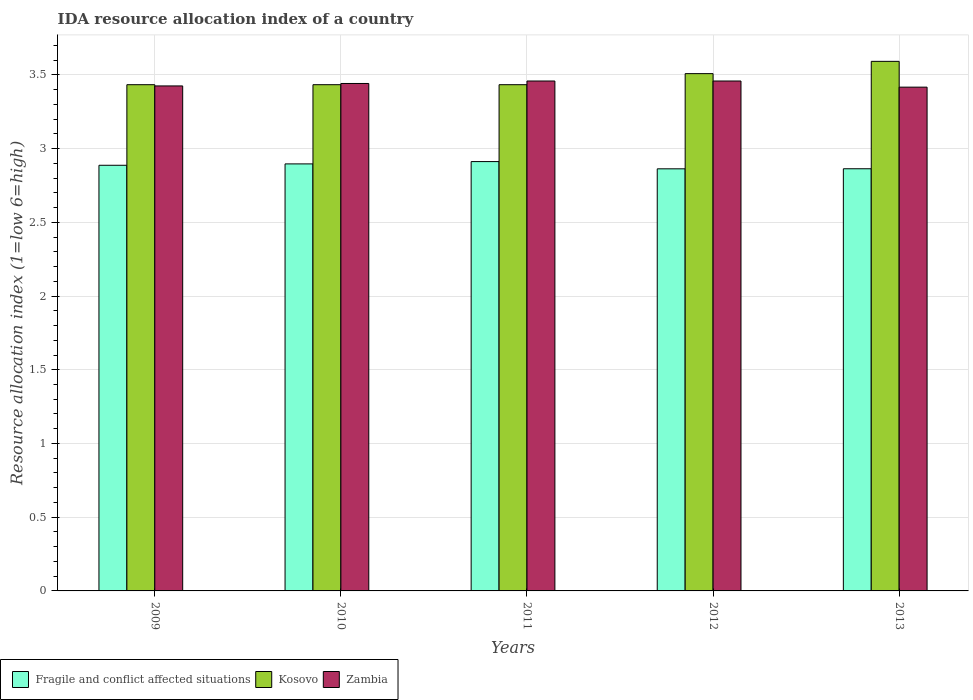Are the number of bars on each tick of the X-axis equal?
Your answer should be compact. Yes. How many bars are there on the 1st tick from the right?
Give a very brief answer. 3. What is the label of the 2nd group of bars from the left?
Keep it short and to the point. 2010. In how many cases, is the number of bars for a given year not equal to the number of legend labels?
Ensure brevity in your answer.  0. What is the IDA resource allocation index in Kosovo in 2009?
Offer a very short reply. 3.43. Across all years, what is the maximum IDA resource allocation index in Fragile and conflict affected situations?
Your answer should be compact. 2.91. Across all years, what is the minimum IDA resource allocation index in Kosovo?
Give a very brief answer. 3.43. In which year was the IDA resource allocation index in Fragile and conflict affected situations minimum?
Keep it short and to the point. 2012. What is the total IDA resource allocation index in Fragile and conflict affected situations in the graph?
Give a very brief answer. 14.42. What is the difference between the IDA resource allocation index in Zambia in 2010 and that in 2013?
Offer a very short reply. 0.02. What is the difference between the IDA resource allocation index in Kosovo in 2010 and the IDA resource allocation index in Fragile and conflict affected situations in 2013?
Provide a short and direct response. 0.57. What is the average IDA resource allocation index in Zambia per year?
Give a very brief answer. 3.44. In the year 2013, what is the difference between the IDA resource allocation index in Kosovo and IDA resource allocation index in Zambia?
Offer a very short reply. 0.17. In how many years, is the IDA resource allocation index in Kosovo greater than 1.2?
Provide a short and direct response. 5. What is the ratio of the IDA resource allocation index in Fragile and conflict affected situations in 2010 to that in 2012?
Ensure brevity in your answer.  1.01. Is the difference between the IDA resource allocation index in Kosovo in 2011 and 2013 greater than the difference between the IDA resource allocation index in Zambia in 2011 and 2013?
Ensure brevity in your answer.  No. What is the difference between the highest and the second highest IDA resource allocation index in Kosovo?
Offer a terse response. 0.08. What is the difference between the highest and the lowest IDA resource allocation index in Zambia?
Offer a terse response. 0.04. In how many years, is the IDA resource allocation index in Kosovo greater than the average IDA resource allocation index in Kosovo taken over all years?
Your answer should be compact. 2. Is the sum of the IDA resource allocation index in Kosovo in 2010 and 2012 greater than the maximum IDA resource allocation index in Zambia across all years?
Provide a succinct answer. Yes. What does the 1st bar from the left in 2011 represents?
Make the answer very short. Fragile and conflict affected situations. What does the 3rd bar from the right in 2011 represents?
Keep it short and to the point. Fragile and conflict affected situations. Is it the case that in every year, the sum of the IDA resource allocation index in Zambia and IDA resource allocation index in Fragile and conflict affected situations is greater than the IDA resource allocation index in Kosovo?
Your answer should be very brief. Yes. How many bars are there?
Provide a succinct answer. 15. Are all the bars in the graph horizontal?
Offer a very short reply. No. Does the graph contain any zero values?
Offer a terse response. No. Where does the legend appear in the graph?
Give a very brief answer. Bottom left. How are the legend labels stacked?
Make the answer very short. Horizontal. What is the title of the graph?
Keep it short and to the point. IDA resource allocation index of a country. What is the label or title of the Y-axis?
Provide a short and direct response. Resource allocation index (1=low 6=high). What is the Resource allocation index (1=low 6=high) of Fragile and conflict affected situations in 2009?
Your answer should be compact. 2.89. What is the Resource allocation index (1=low 6=high) in Kosovo in 2009?
Provide a short and direct response. 3.43. What is the Resource allocation index (1=low 6=high) in Zambia in 2009?
Provide a short and direct response. 3.42. What is the Resource allocation index (1=low 6=high) of Fragile and conflict affected situations in 2010?
Provide a short and direct response. 2.9. What is the Resource allocation index (1=low 6=high) of Kosovo in 2010?
Provide a succinct answer. 3.43. What is the Resource allocation index (1=low 6=high) in Zambia in 2010?
Provide a succinct answer. 3.44. What is the Resource allocation index (1=low 6=high) of Fragile and conflict affected situations in 2011?
Your response must be concise. 2.91. What is the Resource allocation index (1=low 6=high) in Kosovo in 2011?
Your answer should be very brief. 3.43. What is the Resource allocation index (1=low 6=high) of Zambia in 2011?
Your answer should be very brief. 3.46. What is the Resource allocation index (1=low 6=high) of Fragile and conflict affected situations in 2012?
Provide a short and direct response. 2.86. What is the Resource allocation index (1=low 6=high) of Kosovo in 2012?
Provide a short and direct response. 3.51. What is the Resource allocation index (1=low 6=high) in Zambia in 2012?
Offer a terse response. 3.46. What is the Resource allocation index (1=low 6=high) of Fragile and conflict affected situations in 2013?
Give a very brief answer. 2.86. What is the Resource allocation index (1=low 6=high) of Kosovo in 2013?
Provide a short and direct response. 3.59. What is the Resource allocation index (1=low 6=high) of Zambia in 2013?
Your response must be concise. 3.42. Across all years, what is the maximum Resource allocation index (1=low 6=high) in Fragile and conflict affected situations?
Your response must be concise. 2.91. Across all years, what is the maximum Resource allocation index (1=low 6=high) in Kosovo?
Offer a very short reply. 3.59. Across all years, what is the maximum Resource allocation index (1=low 6=high) in Zambia?
Keep it short and to the point. 3.46. Across all years, what is the minimum Resource allocation index (1=low 6=high) of Fragile and conflict affected situations?
Ensure brevity in your answer.  2.86. Across all years, what is the minimum Resource allocation index (1=low 6=high) in Kosovo?
Keep it short and to the point. 3.43. Across all years, what is the minimum Resource allocation index (1=low 6=high) of Zambia?
Give a very brief answer. 3.42. What is the total Resource allocation index (1=low 6=high) in Fragile and conflict affected situations in the graph?
Keep it short and to the point. 14.42. What is the total Resource allocation index (1=low 6=high) in Kosovo in the graph?
Keep it short and to the point. 17.4. What is the total Resource allocation index (1=low 6=high) in Zambia in the graph?
Provide a succinct answer. 17.2. What is the difference between the Resource allocation index (1=low 6=high) in Fragile and conflict affected situations in 2009 and that in 2010?
Provide a succinct answer. -0.01. What is the difference between the Resource allocation index (1=low 6=high) of Zambia in 2009 and that in 2010?
Your answer should be compact. -0.02. What is the difference between the Resource allocation index (1=low 6=high) in Fragile and conflict affected situations in 2009 and that in 2011?
Provide a short and direct response. -0.03. What is the difference between the Resource allocation index (1=low 6=high) in Zambia in 2009 and that in 2011?
Your answer should be very brief. -0.03. What is the difference between the Resource allocation index (1=low 6=high) in Fragile and conflict affected situations in 2009 and that in 2012?
Provide a short and direct response. 0.02. What is the difference between the Resource allocation index (1=low 6=high) of Kosovo in 2009 and that in 2012?
Your answer should be compact. -0.07. What is the difference between the Resource allocation index (1=low 6=high) in Zambia in 2009 and that in 2012?
Your answer should be compact. -0.03. What is the difference between the Resource allocation index (1=low 6=high) of Fragile and conflict affected situations in 2009 and that in 2013?
Offer a very short reply. 0.02. What is the difference between the Resource allocation index (1=low 6=high) in Kosovo in 2009 and that in 2013?
Make the answer very short. -0.16. What is the difference between the Resource allocation index (1=low 6=high) of Zambia in 2009 and that in 2013?
Offer a terse response. 0.01. What is the difference between the Resource allocation index (1=low 6=high) in Fragile and conflict affected situations in 2010 and that in 2011?
Make the answer very short. -0.02. What is the difference between the Resource allocation index (1=low 6=high) in Kosovo in 2010 and that in 2011?
Your answer should be compact. 0. What is the difference between the Resource allocation index (1=low 6=high) in Zambia in 2010 and that in 2011?
Provide a short and direct response. -0.02. What is the difference between the Resource allocation index (1=low 6=high) in Fragile and conflict affected situations in 2010 and that in 2012?
Offer a very short reply. 0.03. What is the difference between the Resource allocation index (1=low 6=high) in Kosovo in 2010 and that in 2012?
Offer a terse response. -0.07. What is the difference between the Resource allocation index (1=low 6=high) of Zambia in 2010 and that in 2012?
Provide a short and direct response. -0.02. What is the difference between the Resource allocation index (1=low 6=high) in Fragile and conflict affected situations in 2010 and that in 2013?
Your response must be concise. 0.03. What is the difference between the Resource allocation index (1=low 6=high) in Kosovo in 2010 and that in 2013?
Ensure brevity in your answer.  -0.16. What is the difference between the Resource allocation index (1=low 6=high) of Zambia in 2010 and that in 2013?
Offer a terse response. 0.03. What is the difference between the Resource allocation index (1=low 6=high) in Fragile and conflict affected situations in 2011 and that in 2012?
Make the answer very short. 0.05. What is the difference between the Resource allocation index (1=low 6=high) in Kosovo in 2011 and that in 2012?
Make the answer very short. -0.07. What is the difference between the Resource allocation index (1=low 6=high) in Zambia in 2011 and that in 2012?
Your response must be concise. 0. What is the difference between the Resource allocation index (1=low 6=high) in Fragile and conflict affected situations in 2011 and that in 2013?
Make the answer very short. 0.05. What is the difference between the Resource allocation index (1=low 6=high) of Kosovo in 2011 and that in 2013?
Ensure brevity in your answer.  -0.16. What is the difference between the Resource allocation index (1=low 6=high) in Zambia in 2011 and that in 2013?
Offer a very short reply. 0.04. What is the difference between the Resource allocation index (1=low 6=high) of Fragile and conflict affected situations in 2012 and that in 2013?
Keep it short and to the point. -0. What is the difference between the Resource allocation index (1=low 6=high) in Kosovo in 2012 and that in 2013?
Your answer should be very brief. -0.08. What is the difference between the Resource allocation index (1=low 6=high) in Zambia in 2012 and that in 2013?
Your answer should be compact. 0.04. What is the difference between the Resource allocation index (1=low 6=high) in Fragile and conflict affected situations in 2009 and the Resource allocation index (1=low 6=high) in Kosovo in 2010?
Provide a succinct answer. -0.55. What is the difference between the Resource allocation index (1=low 6=high) in Fragile and conflict affected situations in 2009 and the Resource allocation index (1=low 6=high) in Zambia in 2010?
Your answer should be very brief. -0.55. What is the difference between the Resource allocation index (1=low 6=high) in Kosovo in 2009 and the Resource allocation index (1=low 6=high) in Zambia in 2010?
Offer a very short reply. -0.01. What is the difference between the Resource allocation index (1=low 6=high) in Fragile and conflict affected situations in 2009 and the Resource allocation index (1=low 6=high) in Kosovo in 2011?
Provide a short and direct response. -0.55. What is the difference between the Resource allocation index (1=low 6=high) in Fragile and conflict affected situations in 2009 and the Resource allocation index (1=low 6=high) in Zambia in 2011?
Make the answer very short. -0.57. What is the difference between the Resource allocation index (1=low 6=high) in Kosovo in 2009 and the Resource allocation index (1=low 6=high) in Zambia in 2011?
Your response must be concise. -0.03. What is the difference between the Resource allocation index (1=low 6=high) of Fragile and conflict affected situations in 2009 and the Resource allocation index (1=low 6=high) of Kosovo in 2012?
Provide a succinct answer. -0.62. What is the difference between the Resource allocation index (1=low 6=high) in Fragile and conflict affected situations in 2009 and the Resource allocation index (1=low 6=high) in Zambia in 2012?
Give a very brief answer. -0.57. What is the difference between the Resource allocation index (1=low 6=high) in Kosovo in 2009 and the Resource allocation index (1=low 6=high) in Zambia in 2012?
Ensure brevity in your answer.  -0.03. What is the difference between the Resource allocation index (1=low 6=high) in Fragile and conflict affected situations in 2009 and the Resource allocation index (1=low 6=high) in Kosovo in 2013?
Provide a short and direct response. -0.7. What is the difference between the Resource allocation index (1=low 6=high) in Fragile and conflict affected situations in 2009 and the Resource allocation index (1=low 6=high) in Zambia in 2013?
Your answer should be very brief. -0.53. What is the difference between the Resource allocation index (1=low 6=high) of Kosovo in 2009 and the Resource allocation index (1=low 6=high) of Zambia in 2013?
Your answer should be compact. 0.02. What is the difference between the Resource allocation index (1=low 6=high) of Fragile and conflict affected situations in 2010 and the Resource allocation index (1=low 6=high) of Kosovo in 2011?
Ensure brevity in your answer.  -0.54. What is the difference between the Resource allocation index (1=low 6=high) in Fragile and conflict affected situations in 2010 and the Resource allocation index (1=low 6=high) in Zambia in 2011?
Provide a short and direct response. -0.56. What is the difference between the Resource allocation index (1=low 6=high) in Kosovo in 2010 and the Resource allocation index (1=low 6=high) in Zambia in 2011?
Your answer should be very brief. -0.03. What is the difference between the Resource allocation index (1=low 6=high) in Fragile and conflict affected situations in 2010 and the Resource allocation index (1=low 6=high) in Kosovo in 2012?
Provide a succinct answer. -0.61. What is the difference between the Resource allocation index (1=low 6=high) in Fragile and conflict affected situations in 2010 and the Resource allocation index (1=low 6=high) in Zambia in 2012?
Your answer should be compact. -0.56. What is the difference between the Resource allocation index (1=low 6=high) of Kosovo in 2010 and the Resource allocation index (1=low 6=high) of Zambia in 2012?
Your response must be concise. -0.03. What is the difference between the Resource allocation index (1=low 6=high) in Fragile and conflict affected situations in 2010 and the Resource allocation index (1=low 6=high) in Kosovo in 2013?
Provide a short and direct response. -0.7. What is the difference between the Resource allocation index (1=low 6=high) of Fragile and conflict affected situations in 2010 and the Resource allocation index (1=low 6=high) of Zambia in 2013?
Provide a succinct answer. -0.52. What is the difference between the Resource allocation index (1=low 6=high) in Kosovo in 2010 and the Resource allocation index (1=low 6=high) in Zambia in 2013?
Keep it short and to the point. 0.02. What is the difference between the Resource allocation index (1=low 6=high) of Fragile and conflict affected situations in 2011 and the Resource allocation index (1=low 6=high) of Kosovo in 2012?
Give a very brief answer. -0.6. What is the difference between the Resource allocation index (1=low 6=high) of Fragile and conflict affected situations in 2011 and the Resource allocation index (1=low 6=high) of Zambia in 2012?
Offer a very short reply. -0.55. What is the difference between the Resource allocation index (1=low 6=high) of Kosovo in 2011 and the Resource allocation index (1=low 6=high) of Zambia in 2012?
Offer a very short reply. -0.03. What is the difference between the Resource allocation index (1=low 6=high) of Fragile and conflict affected situations in 2011 and the Resource allocation index (1=low 6=high) of Kosovo in 2013?
Provide a short and direct response. -0.68. What is the difference between the Resource allocation index (1=low 6=high) in Fragile and conflict affected situations in 2011 and the Resource allocation index (1=low 6=high) in Zambia in 2013?
Offer a terse response. -0.5. What is the difference between the Resource allocation index (1=low 6=high) in Kosovo in 2011 and the Resource allocation index (1=low 6=high) in Zambia in 2013?
Your response must be concise. 0.02. What is the difference between the Resource allocation index (1=low 6=high) of Fragile and conflict affected situations in 2012 and the Resource allocation index (1=low 6=high) of Kosovo in 2013?
Offer a terse response. -0.73. What is the difference between the Resource allocation index (1=low 6=high) of Fragile and conflict affected situations in 2012 and the Resource allocation index (1=low 6=high) of Zambia in 2013?
Give a very brief answer. -0.55. What is the difference between the Resource allocation index (1=low 6=high) of Kosovo in 2012 and the Resource allocation index (1=low 6=high) of Zambia in 2013?
Provide a succinct answer. 0.09. What is the average Resource allocation index (1=low 6=high) of Fragile and conflict affected situations per year?
Your answer should be very brief. 2.88. What is the average Resource allocation index (1=low 6=high) in Kosovo per year?
Your answer should be compact. 3.48. What is the average Resource allocation index (1=low 6=high) of Zambia per year?
Ensure brevity in your answer.  3.44. In the year 2009, what is the difference between the Resource allocation index (1=low 6=high) of Fragile and conflict affected situations and Resource allocation index (1=low 6=high) of Kosovo?
Give a very brief answer. -0.55. In the year 2009, what is the difference between the Resource allocation index (1=low 6=high) in Fragile and conflict affected situations and Resource allocation index (1=low 6=high) in Zambia?
Your answer should be compact. -0.54. In the year 2009, what is the difference between the Resource allocation index (1=low 6=high) of Kosovo and Resource allocation index (1=low 6=high) of Zambia?
Provide a succinct answer. 0.01. In the year 2010, what is the difference between the Resource allocation index (1=low 6=high) of Fragile and conflict affected situations and Resource allocation index (1=low 6=high) of Kosovo?
Keep it short and to the point. -0.54. In the year 2010, what is the difference between the Resource allocation index (1=low 6=high) in Fragile and conflict affected situations and Resource allocation index (1=low 6=high) in Zambia?
Your response must be concise. -0.55. In the year 2010, what is the difference between the Resource allocation index (1=low 6=high) of Kosovo and Resource allocation index (1=low 6=high) of Zambia?
Your answer should be compact. -0.01. In the year 2011, what is the difference between the Resource allocation index (1=low 6=high) of Fragile and conflict affected situations and Resource allocation index (1=low 6=high) of Kosovo?
Make the answer very short. -0.52. In the year 2011, what is the difference between the Resource allocation index (1=low 6=high) in Fragile and conflict affected situations and Resource allocation index (1=low 6=high) in Zambia?
Your response must be concise. -0.55. In the year 2011, what is the difference between the Resource allocation index (1=low 6=high) of Kosovo and Resource allocation index (1=low 6=high) of Zambia?
Make the answer very short. -0.03. In the year 2012, what is the difference between the Resource allocation index (1=low 6=high) of Fragile and conflict affected situations and Resource allocation index (1=low 6=high) of Kosovo?
Provide a short and direct response. -0.65. In the year 2012, what is the difference between the Resource allocation index (1=low 6=high) of Fragile and conflict affected situations and Resource allocation index (1=low 6=high) of Zambia?
Your answer should be very brief. -0.6. In the year 2012, what is the difference between the Resource allocation index (1=low 6=high) of Kosovo and Resource allocation index (1=low 6=high) of Zambia?
Provide a short and direct response. 0.05. In the year 2013, what is the difference between the Resource allocation index (1=low 6=high) of Fragile and conflict affected situations and Resource allocation index (1=low 6=high) of Kosovo?
Your response must be concise. -0.73. In the year 2013, what is the difference between the Resource allocation index (1=low 6=high) of Fragile and conflict affected situations and Resource allocation index (1=low 6=high) of Zambia?
Offer a very short reply. -0.55. In the year 2013, what is the difference between the Resource allocation index (1=low 6=high) of Kosovo and Resource allocation index (1=low 6=high) of Zambia?
Provide a short and direct response. 0.17. What is the ratio of the Resource allocation index (1=low 6=high) of Zambia in 2009 to that in 2010?
Ensure brevity in your answer.  1. What is the ratio of the Resource allocation index (1=low 6=high) of Kosovo in 2009 to that in 2011?
Your answer should be compact. 1. What is the ratio of the Resource allocation index (1=low 6=high) in Fragile and conflict affected situations in 2009 to that in 2012?
Provide a succinct answer. 1.01. What is the ratio of the Resource allocation index (1=low 6=high) in Kosovo in 2009 to that in 2012?
Give a very brief answer. 0.98. What is the ratio of the Resource allocation index (1=low 6=high) of Fragile and conflict affected situations in 2009 to that in 2013?
Offer a terse response. 1.01. What is the ratio of the Resource allocation index (1=low 6=high) of Kosovo in 2009 to that in 2013?
Give a very brief answer. 0.96. What is the ratio of the Resource allocation index (1=low 6=high) in Kosovo in 2010 to that in 2011?
Offer a very short reply. 1. What is the ratio of the Resource allocation index (1=low 6=high) of Zambia in 2010 to that in 2011?
Ensure brevity in your answer.  1. What is the ratio of the Resource allocation index (1=low 6=high) in Fragile and conflict affected situations in 2010 to that in 2012?
Make the answer very short. 1.01. What is the ratio of the Resource allocation index (1=low 6=high) of Kosovo in 2010 to that in 2012?
Ensure brevity in your answer.  0.98. What is the ratio of the Resource allocation index (1=low 6=high) in Zambia in 2010 to that in 2012?
Offer a very short reply. 1. What is the ratio of the Resource allocation index (1=low 6=high) of Fragile and conflict affected situations in 2010 to that in 2013?
Your answer should be compact. 1.01. What is the ratio of the Resource allocation index (1=low 6=high) in Kosovo in 2010 to that in 2013?
Keep it short and to the point. 0.96. What is the ratio of the Resource allocation index (1=low 6=high) of Zambia in 2010 to that in 2013?
Offer a very short reply. 1.01. What is the ratio of the Resource allocation index (1=low 6=high) of Fragile and conflict affected situations in 2011 to that in 2012?
Your answer should be very brief. 1.02. What is the ratio of the Resource allocation index (1=low 6=high) of Kosovo in 2011 to that in 2012?
Ensure brevity in your answer.  0.98. What is the ratio of the Resource allocation index (1=low 6=high) of Fragile and conflict affected situations in 2011 to that in 2013?
Provide a short and direct response. 1.02. What is the ratio of the Resource allocation index (1=low 6=high) in Kosovo in 2011 to that in 2013?
Offer a very short reply. 0.96. What is the ratio of the Resource allocation index (1=low 6=high) of Zambia in 2011 to that in 2013?
Keep it short and to the point. 1.01. What is the ratio of the Resource allocation index (1=low 6=high) of Kosovo in 2012 to that in 2013?
Give a very brief answer. 0.98. What is the ratio of the Resource allocation index (1=low 6=high) in Zambia in 2012 to that in 2013?
Your response must be concise. 1.01. What is the difference between the highest and the second highest Resource allocation index (1=low 6=high) in Fragile and conflict affected situations?
Provide a succinct answer. 0.02. What is the difference between the highest and the second highest Resource allocation index (1=low 6=high) in Kosovo?
Ensure brevity in your answer.  0.08. What is the difference between the highest and the second highest Resource allocation index (1=low 6=high) in Zambia?
Your answer should be compact. 0. What is the difference between the highest and the lowest Resource allocation index (1=low 6=high) of Fragile and conflict affected situations?
Ensure brevity in your answer.  0.05. What is the difference between the highest and the lowest Resource allocation index (1=low 6=high) of Kosovo?
Your answer should be compact. 0.16. What is the difference between the highest and the lowest Resource allocation index (1=low 6=high) of Zambia?
Make the answer very short. 0.04. 